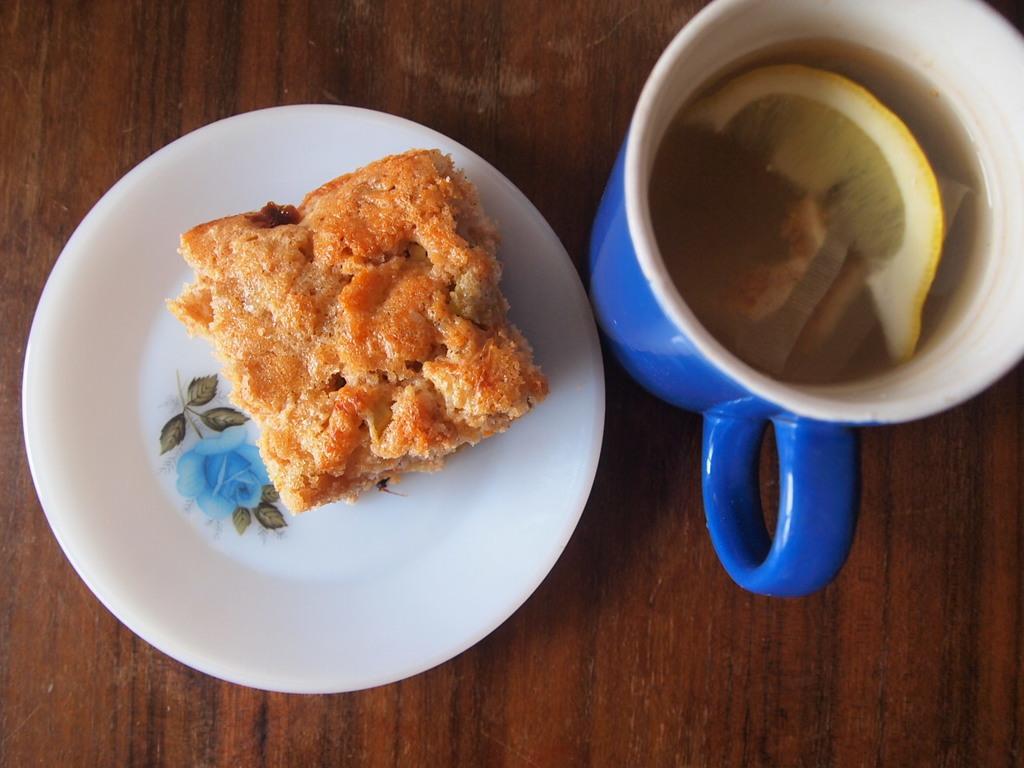In one or two sentences, can you explain what this image depicts? In this image we can see a food item on the plate, beside here is the glass, and some liquid in it, here is the table. 